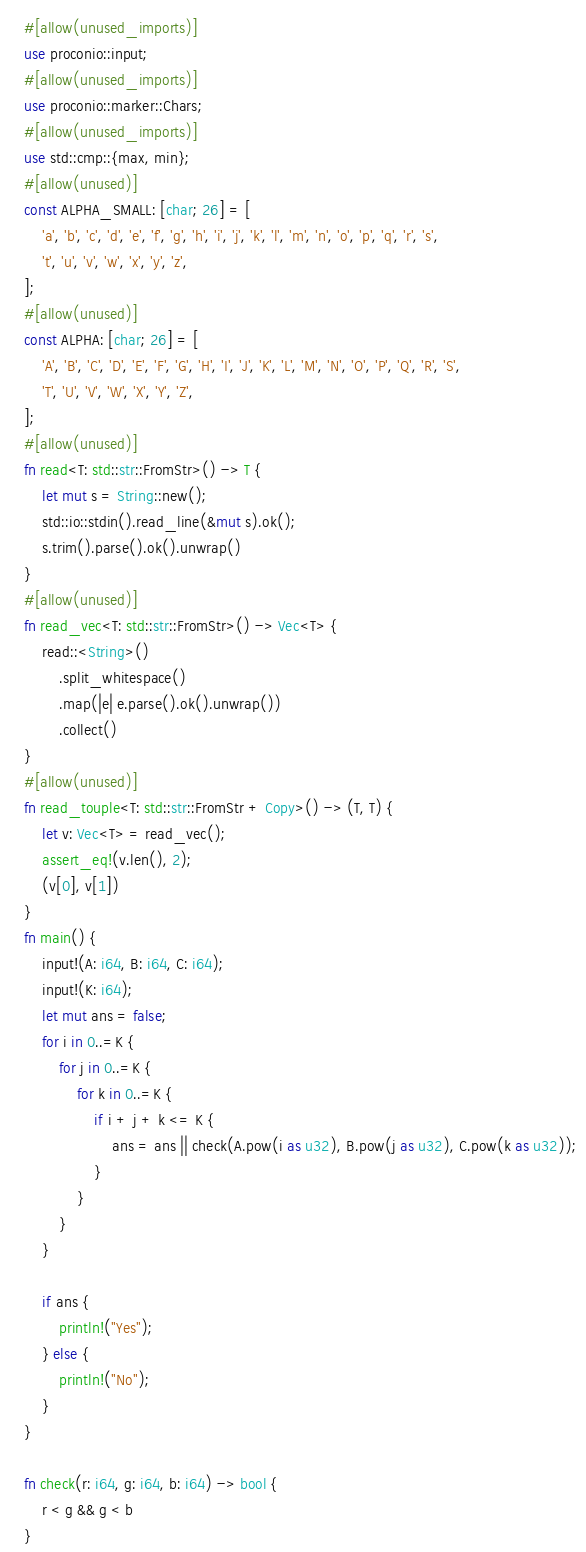Convert code to text. <code><loc_0><loc_0><loc_500><loc_500><_Rust_>#[allow(unused_imports)]
use proconio::input;
#[allow(unused_imports)]
use proconio::marker::Chars;
#[allow(unused_imports)]
use std::cmp::{max, min};
#[allow(unused)]
const ALPHA_SMALL: [char; 26] = [
    'a', 'b', 'c', 'd', 'e', 'f', 'g', 'h', 'i', 'j', 'k', 'l', 'm', 'n', 'o', 'p', 'q', 'r', 's',
    't', 'u', 'v', 'w', 'x', 'y', 'z',
];
#[allow(unused)]
const ALPHA: [char; 26] = [
    'A', 'B', 'C', 'D', 'E', 'F', 'G', 'H', 'I', 'J', 'K', 'L', 'M', 'N', 'O', 'P', 'Q', 'R', 'S',
    'T', 'U', 'V', 'W', 'X', 'Y', 'Z',
];
#[allow(unused)]
fn read<T: std::str::FromStr>() -> T {
    let mut s = String::new();
    std::io::stdin().read_line(&mut s).ok();
    s.trim().parse().ok().unwrap()
}
#[allow(unused)]
fn read_vec<T: std::str::FromStr>() -> Vec<T> {
    read::<String>()
        .split_whitespace()
        .map(|e| e.parse().ok().unwrap())
        .collect()
}
#[allow(unused)]
fn read_touple<T: std::str::FromStr + Copy>() -> (T, T) {
    let v: Vec<T> = read_vec();
    assert_eq!(v.len(), 2);
    (v[0], v[1])
}
fn main() {
    input!(A: i64, B: i64, C: i64);
    input!(K: i64);
    let mut ans = false;
    for i in 0..=K {
        for j in 0..=K {
            for k in 0..=K {
                if i + j + k <= K {
                    ans = ans || check(A.pow(i as u32), B.pow(j as u32), C.pow(k as u32));
                }
            }
        }
    }

    if ans {
        println!("Yes");
    } else {
        println!("No");
    }
}

fn check(r: i64, g: i64, b: i64) -> bool {
    r < g && g < b
}
</code> 